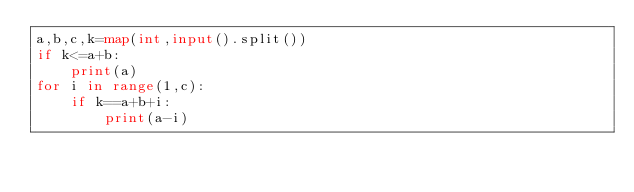<code> <loc_0><loc_0><loc_500><loc_500><_Python_>a,b,c,k=map(int,input().split())
if k<=a+b:
    print(a)
for i in range(1,c):
    if k==a+b+i:
        print(a-i)</code> 